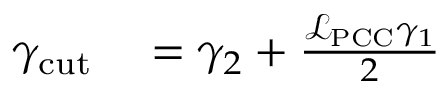Convert formula to latex. <formula><loc_0><loc_0><loc_500><loc_500>\begin{array} { r l } { \gamma _ { c u t } } & = \gamma _ { 2 } + \frac { \mathcal { L } _ { P C C } \gamma _ { 1 } } { 2 } } \end{array}</formula> 